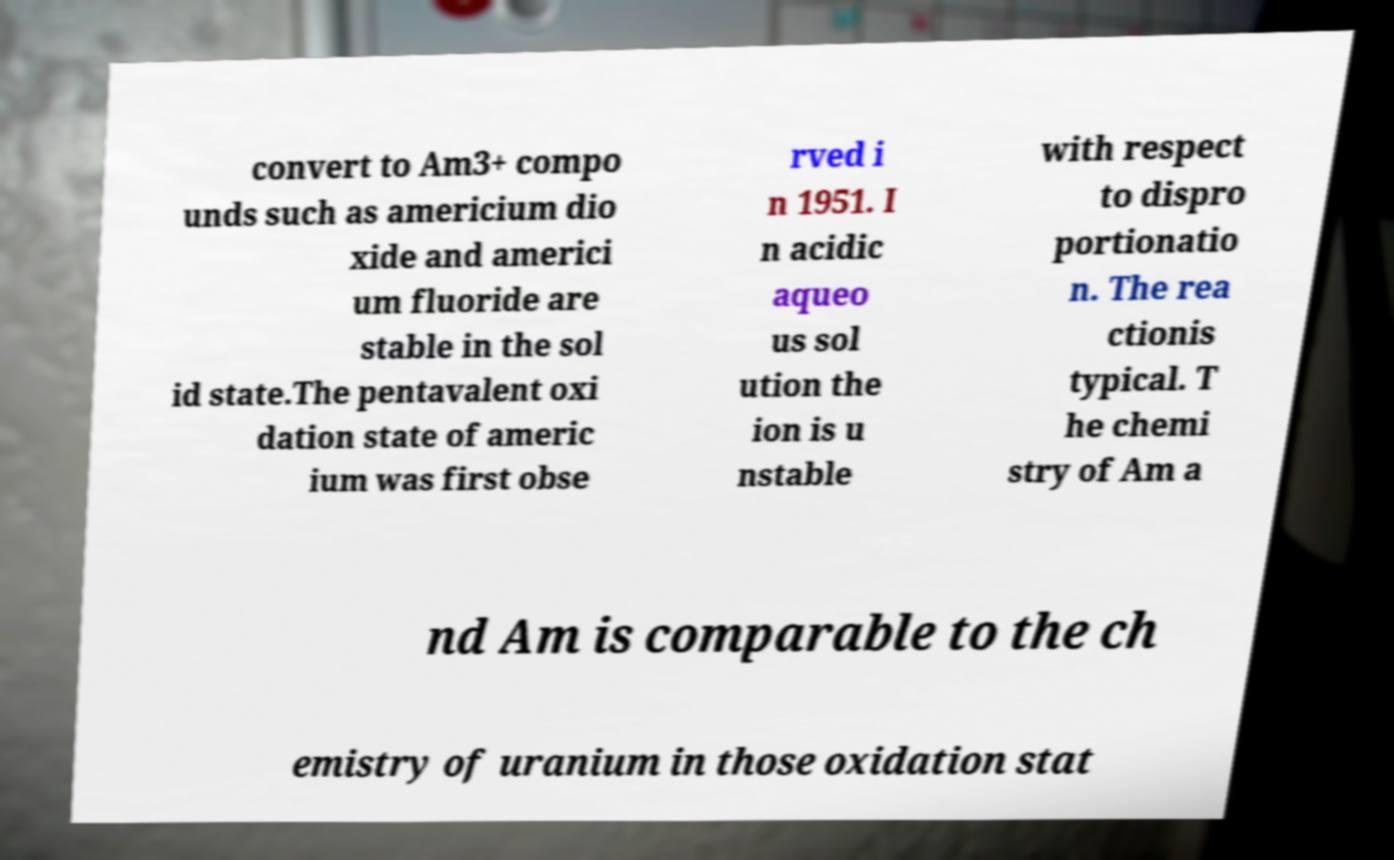Please identify and transcribe the text found in this image. convert to Am3+ compo unds such as americium dio xide and americi um fluoride are stable in the sol id state.The pentavalent oxi dation state of americ ium was first obse rved i n 1951. I n acidic aqueo us sol ution the ion is u nstable with respect to dispro portionatio n. The rea ctionis typical. T he chemi stry of Am a nd Am is comparable to the ch emistry of uranium in those oxidation stat 